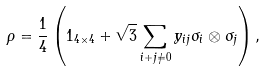Convert formula to latex. <formula><loc_0><loc_0><loc_500><loc_500>\rho = \frac { 1 } { 4 } \left ( 1 _ { 4 \times 4 } + \sqrt { 3 } \sum _ { i + j \neq 0 } y _ { i j } \sigma _ { i } \otimes \sigma _ { j } \right ) ,</formula> 